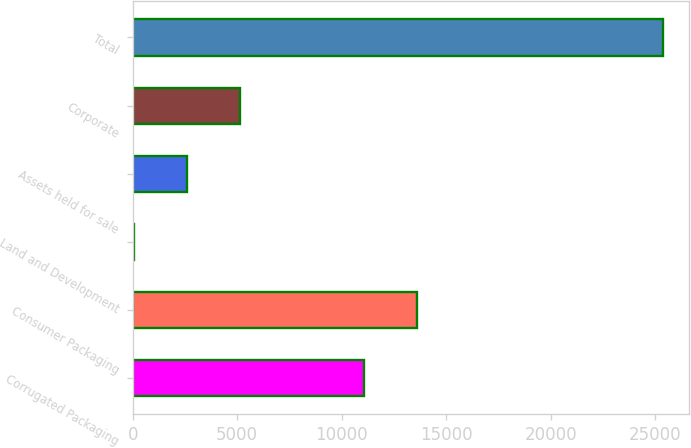Convert chart. <chart><loc_0><loc_0><loc_500><loc_500><bar_chart><fcel>Corrugated Packaging<fcel>Consumer Packaging<fcel>Land and Development<fcel>Assets held for sale<fcel>Corporate<fcel>Total<nl><fcel>11069.6<fcel>13600.7<fcel>49.1<fcel>2580.24<fcel>5111.38<fcel>25360.5<nl></chart> 